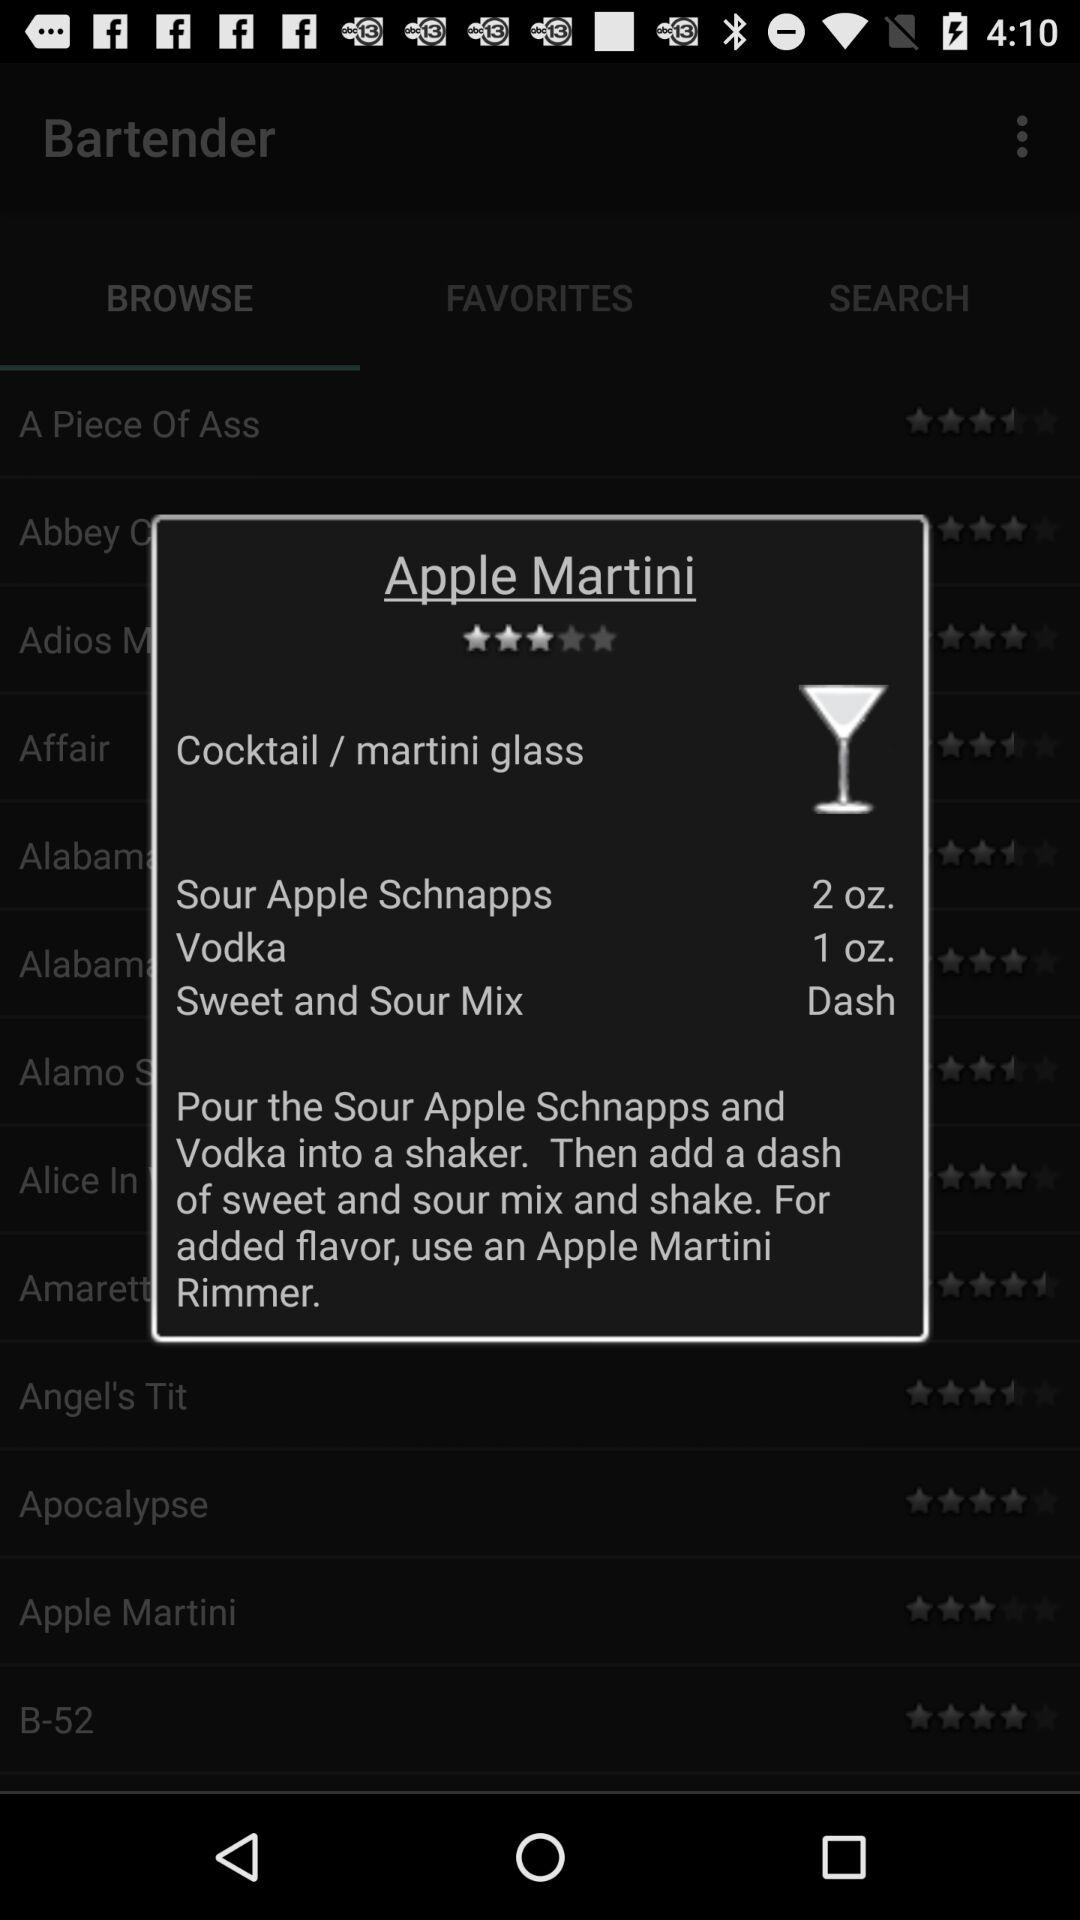What is the drink's name? The drink's name is Apple Martini. 